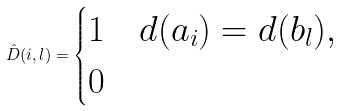<formula> <loc_0><loc_0><loc_500><loc_500>\hat { D } ( i , l ) = \begin{cases} 1 & d ( a _ { i } ) = d ( b _ { l } ) , \\ 0 & \end{cases}</formula> 